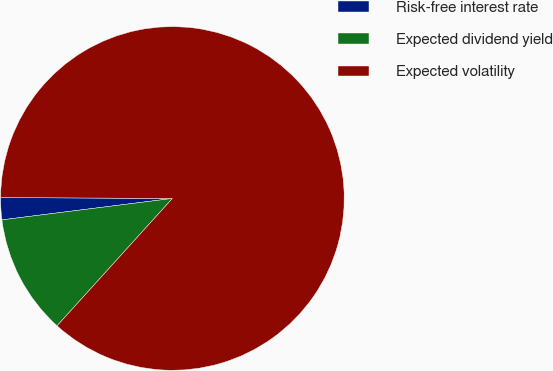Convert chart to OTSL. <chart><loc_0><loc_0><loc_500><loc_500><pie_chart><fcel>Risk-free interest rate<fcel>Expected dividend yield<fcel>Expected volatility<nl><fcel>2.07%<fcel>11.3%<fcel>86.64%<nl></chart> 